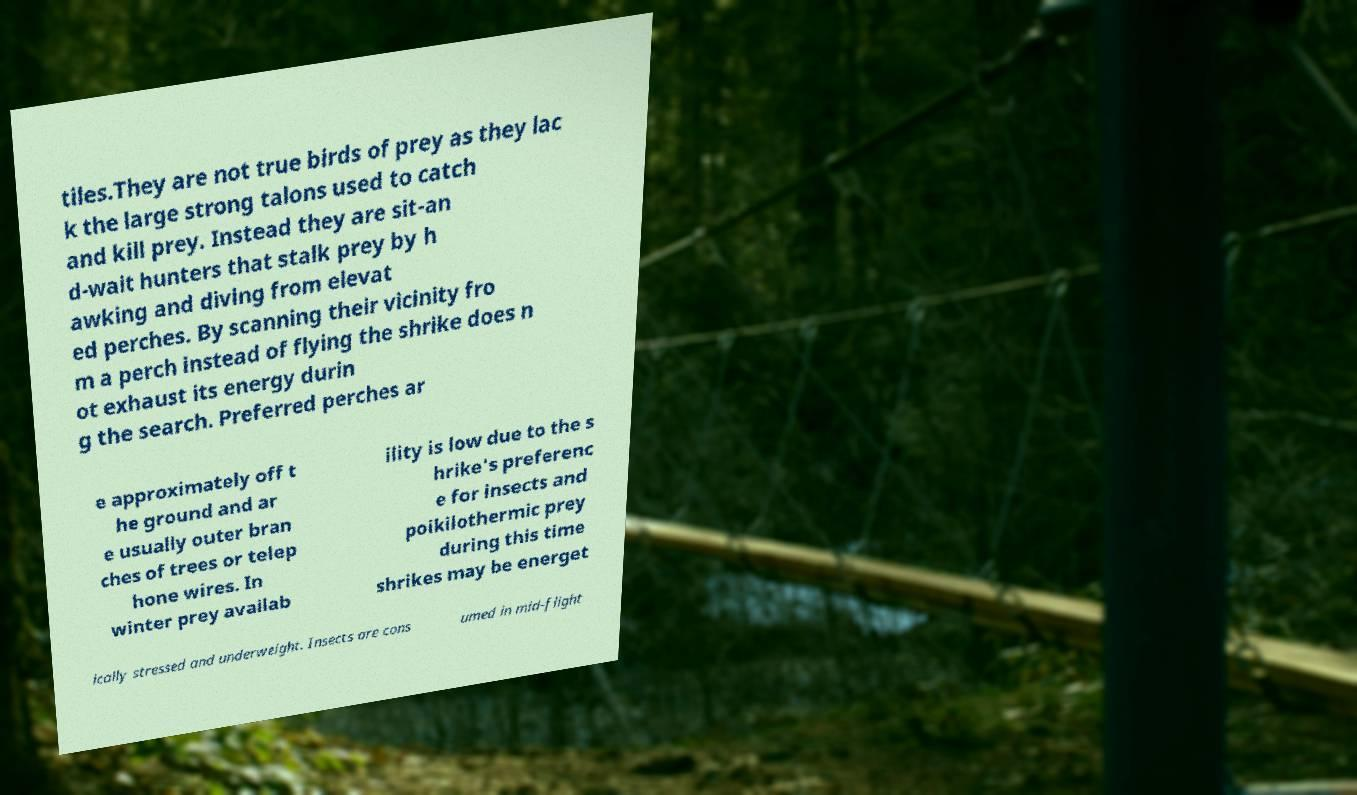Could you assist in decoding the text presented in this image and type it out clearly? tiles.They are not true birds of prey as they lac k the large strong talons used to catch and kill prey. Instead they are sit-an d-wait hunters that stalk prey by h awking and diving from elevat ed perches. By scanning their vicinity fro m a perch instead of flying the shrike does n ot exhaust its energy durin g the search. Preferred perches ar e approximately off t he ground and ar e usually outer bran ches of trees or telep hone wires. In winter prey availab ility is low due to the s hrike's preferenc e for insects and poikilothermic prey during this time shrikes may be energet ically stressed and underweight. Insects are cons umed in mid-flight 